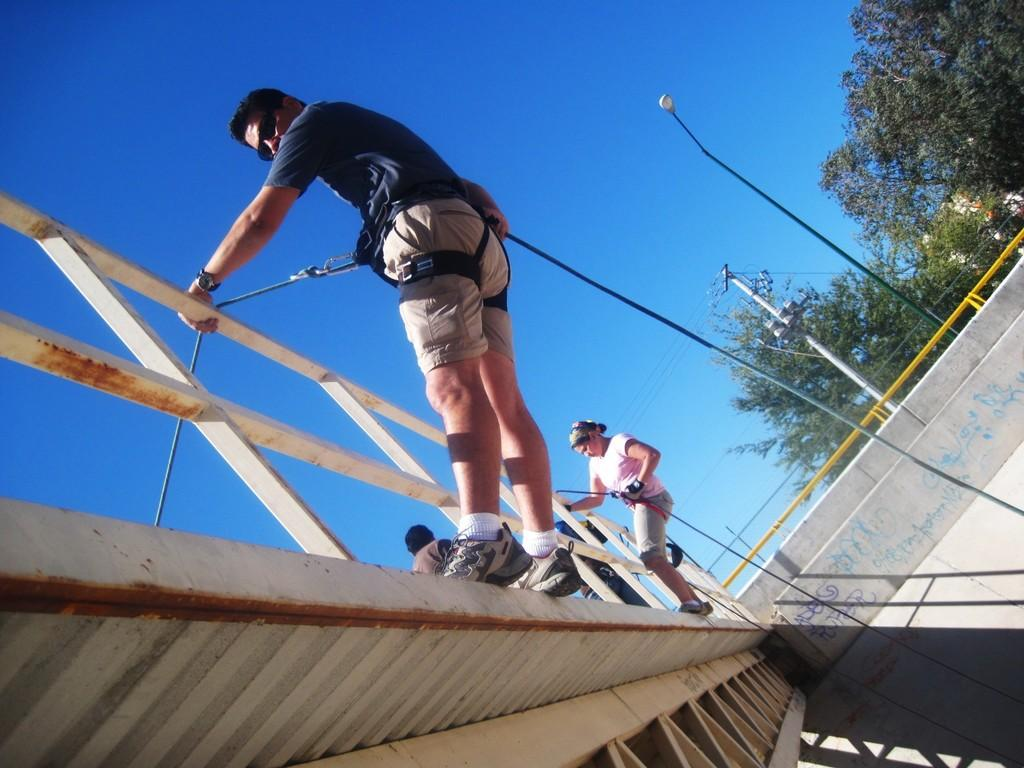What is happening in the image? There is a group of people in the image. Where are the people located? The people are standing on a bridge. What are the people holding onto? The people are holding a wooden railing with their hands. What can be seen in the background of the image? There are poles, trees, and the sky visible in the background of the image. What type of cherry is being used to power the steam engine in the image? There is no steam engine or cherry present in the image. 